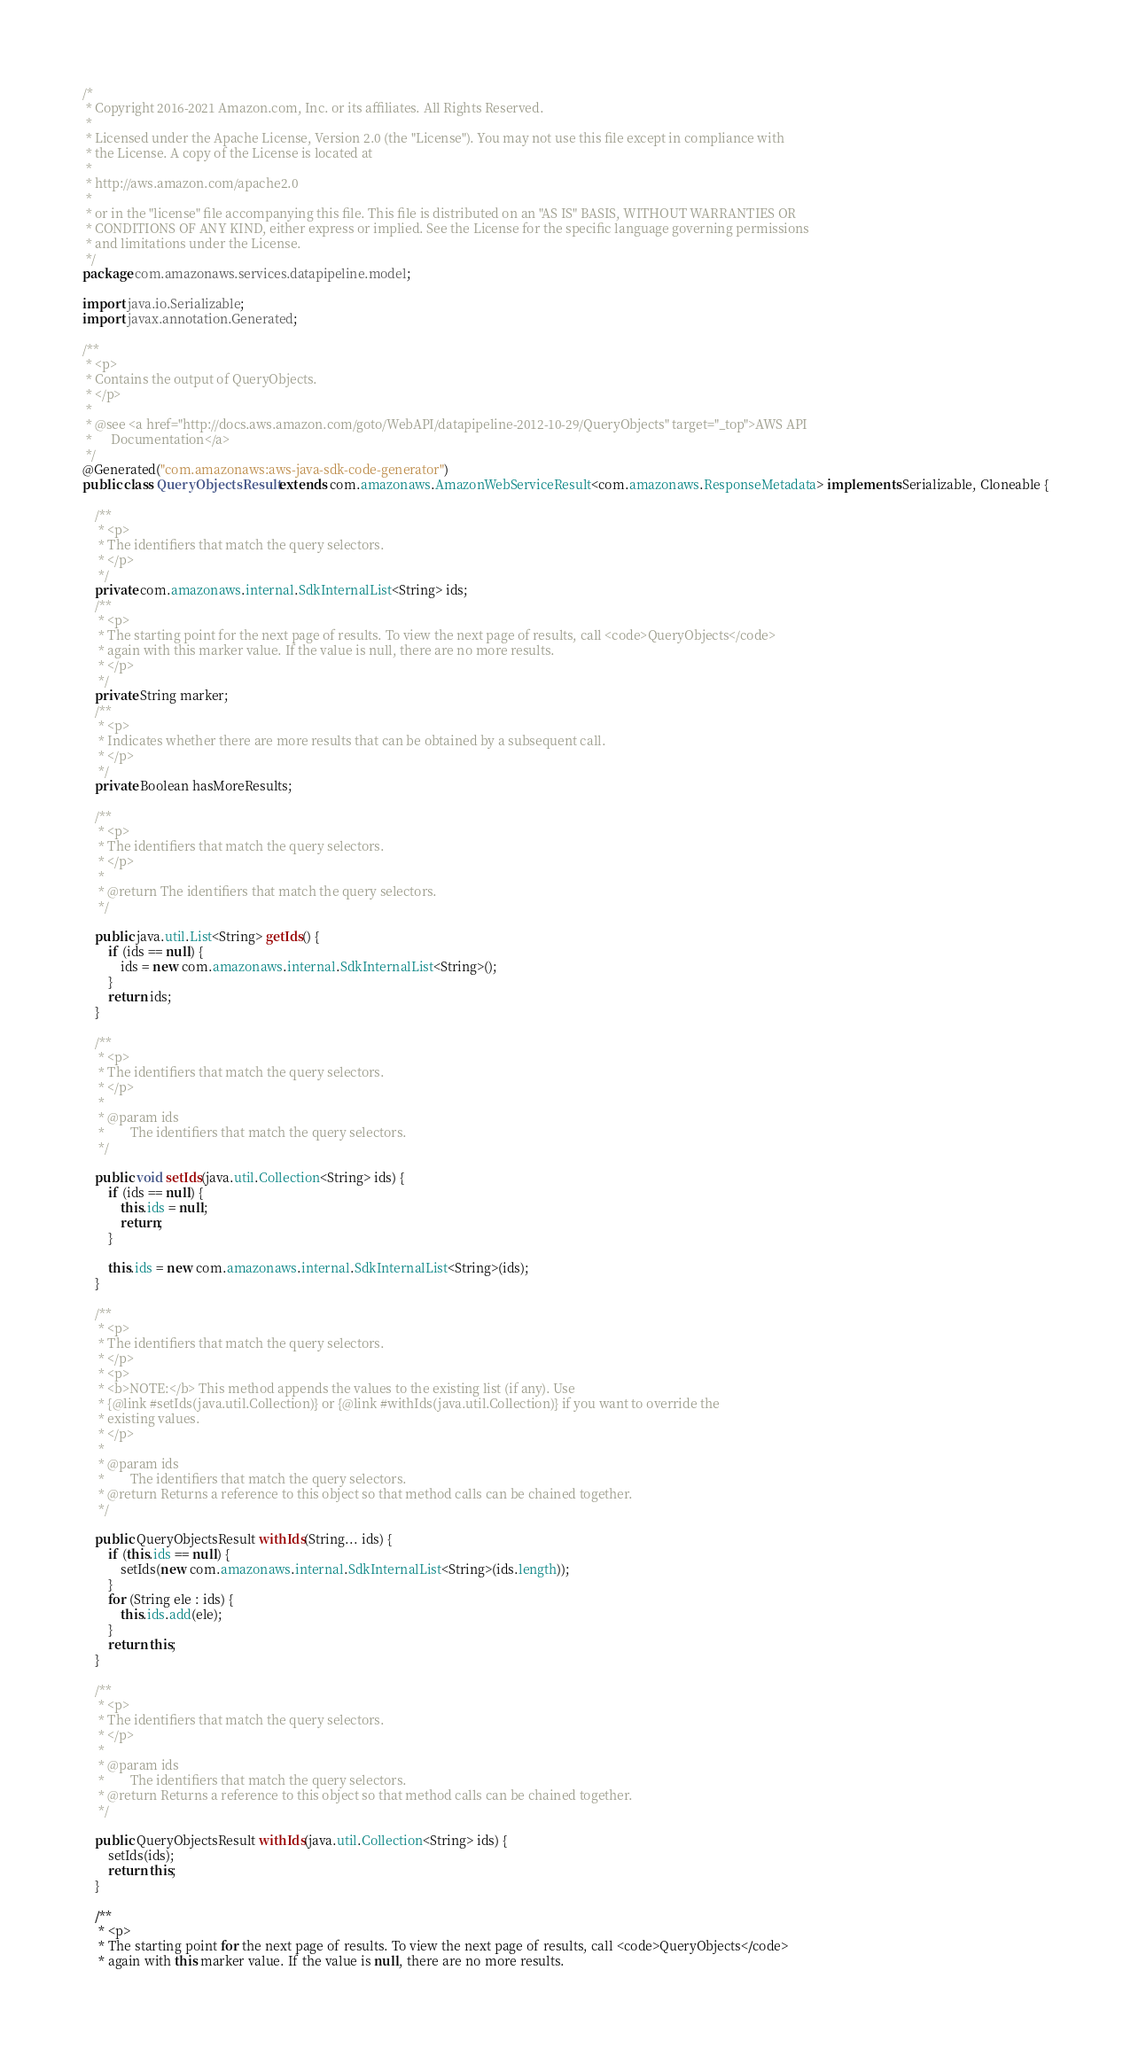<code> <loc_0><loc_0><loc_500><loc_500><_Java_>/*
 * Copyright 2016-2021 Amazon.com, Inc. or its affiliates. All Rights Reserved.
 * 
 * Licensed under the Apache License, Version 2.0 (the "License"). You may not use this file except in compliance with
 * the License. A copy of the License is located at
 * 
 * http://aws.amazon.com/apache2.0
 * 
 * or in the "license" file accompanying this file. This file is distributed on an "AS IS" BASIS, WITHOUT WARRANTIES OR
 * CONDITIONS OF ANY KIND, either express or implied. See the License for the specific language governing permissions
 * and limitations under the License.
 */
package com.amazonaws.services.datapipeline.model;

import java.io.Serializable;
import javax.annotation.Generated;

/**
 * <p>
 * Contains the output of QueryObjects.
 * </p>
 * 
 * @see <a href="http://docs.aws.amazon.com/goto/WebAPI/datapipeline-2012-10-29/QueryObjects" target="_top">AWS API
 *      Documentation</a>
 */
@Generated("com.amazonaws:aws-java-sdk-code-generator")
public class QueryObjectsResult extends com.amazonaws.AmazonWebServiceResult<com.amazonaws.ResponseMetadata> implements Serializable, Cloneable {

    /**
     * <p>
     * The identifiers that match the query selectors.
     * </p>
     */
    private com.amazonaws.internal.SdkInternalList<String> ids;
    /**
     * <p>
     * The starting point for the next page of results. To view the next page of results, call <code>QueryObjects</code>
     * again with this marker value. If the value is null, there are no more results.
     * </p>
     */
    private String marker;
    /**
     * <p>
     * Indicates whether there are more results that can be obtained by a subsequent call.
     * </p>
     */
    private Boolean hasMoreResults;

    /**
     * <p>
     * The identifiers that match the query selectors.
     * </p>
     * 
     * @return The identifiers that match the query selectors.
     */

    public java.util.List<String> getIds() {
        if (ids == null) {
            ids = new com.amazonaws.internal.SdkInternalList<String>();
        }
        return ids;
    }

    /**
     * <p>
     * The identifiers that match the query selectors.
     * </p>
     * 
     * @param ids
     *        The identifiers that match the query selectors.
     */

    public void setIds(java.util.Collection<String> ids) {
        if (ids == null) {
            this.ids = null;
            return;
        }

        this.ids = new com.amazonaws.internal.SdkInternalList<String>(ids);
    }

    /**
     * <p>
     * The identifiers that match the query selectors.
     * </p>
     * <p>
     * <b>NOTE:</b> This method appends the values to the existing list (if any). Use
     * {@link #setIds(java.util.Collection)} or {@link #withIds(java.util.Collection)} if you want to override the
     * existing values.
     * </p>
     * 
     * @param ids
     *        The identifiers that match the query selectors.
     * @return Returns a reference to this object so that method calls can be chained together.
     */

    public QueryObjectsResult withIds(String... ids) {
        if (this.ids == null) {
            setIds(new com.amazonaws.internal.SdkInternalList<String>(ids.length));
        }
        for (String ele : ids) {
            this.ids.add(ele);
        }
        return this;
    }

    /**
     * <p>
     * The identifiers that match the query selectors.
     * </p>
     * 
     * @param ids
     *        The identifiers that match the query selectors.
     * @return Returns a reference to this object so that method calls can be chained together.
     */

    public QueryObjectsResult withIds(java.util.Collection<String> ids) {
        setIds(ids);
        return this;
    }

    /**
     * <p>
     * The starting point for the next page of results. To view the next page of results, call <code>QueryObjects</code>
     * again with this marker value. If the value is null, there are no more results.</code> 